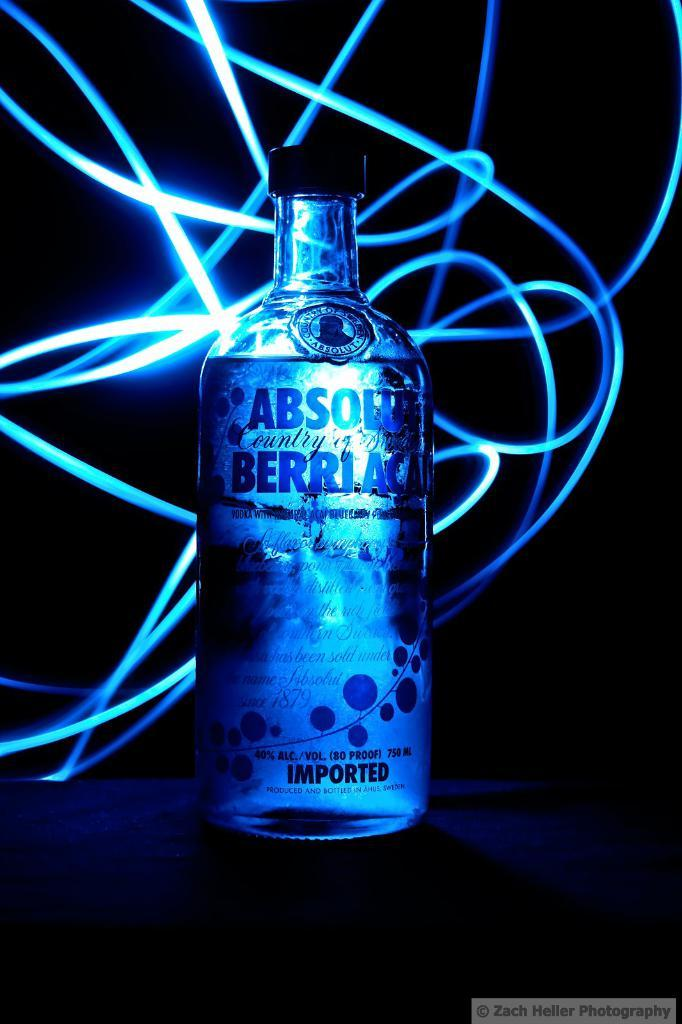<image>
Summarize the visual content of the image. A bottle of alcohol which has the word Absolut on the label. 